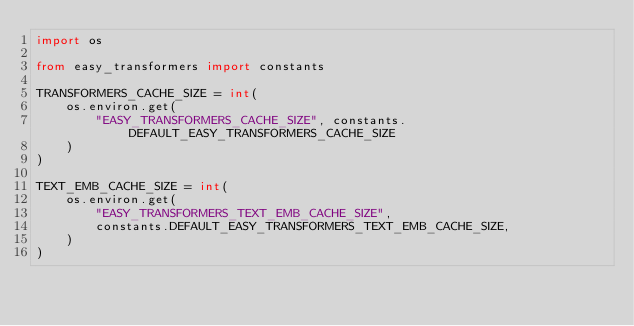Convert code to text. <code><loc_0><loc_0><loc_500><loc_500><_Python_>import os

from easy_transformers import constants

TRANSFORMERS_CACHE_SIZE = int(
    os.environ.get(
        "EASY_TRANSFORMERS_CACHE_SIZE", constants.DEFAULT_EASY_TRANSFORMERS_CACHE_SIZE
    )
)

TEXT_EMB_CACHE_SIZE = int(
    os.environ.get(
        "EASY_TRANSFORMERS_TEXT_EMB_CACHE_SIZE",
        constants.DEFAULT_EASY_TRANSFORMERS_TEXT_EMB_CACHE_SIZE,
    )
)
</code> 